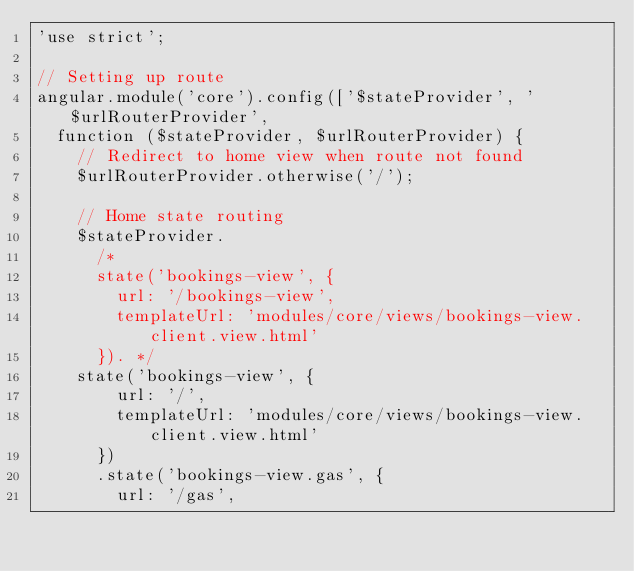<code> <loc_0><loc_0><loc_500><loc_500><_JavaScript_>'use strict';

// Setting up route
angular.module('core').config(['$stateProvider', '$urlRouterProvider',
	function ($stateProvider, $urlRouterProvider) {
		// Redirect to home view when route not found
		$urlRouterProvider.otherwise('/');

		// Home state routing
		$stateProvider.
			/*
			state('bookings-view', {
				url: '/bookings-view',
				templateUrl: 'modules/core/views/bookings-view.client.view.html'
			}). */
		state('bookings-view', {
				url: '/',
				templateUrl: 'modules/core/views/bookings-view.client.view.html'
			})
			.state('bookings-view.gas', {
				url: '/gas',</code> 